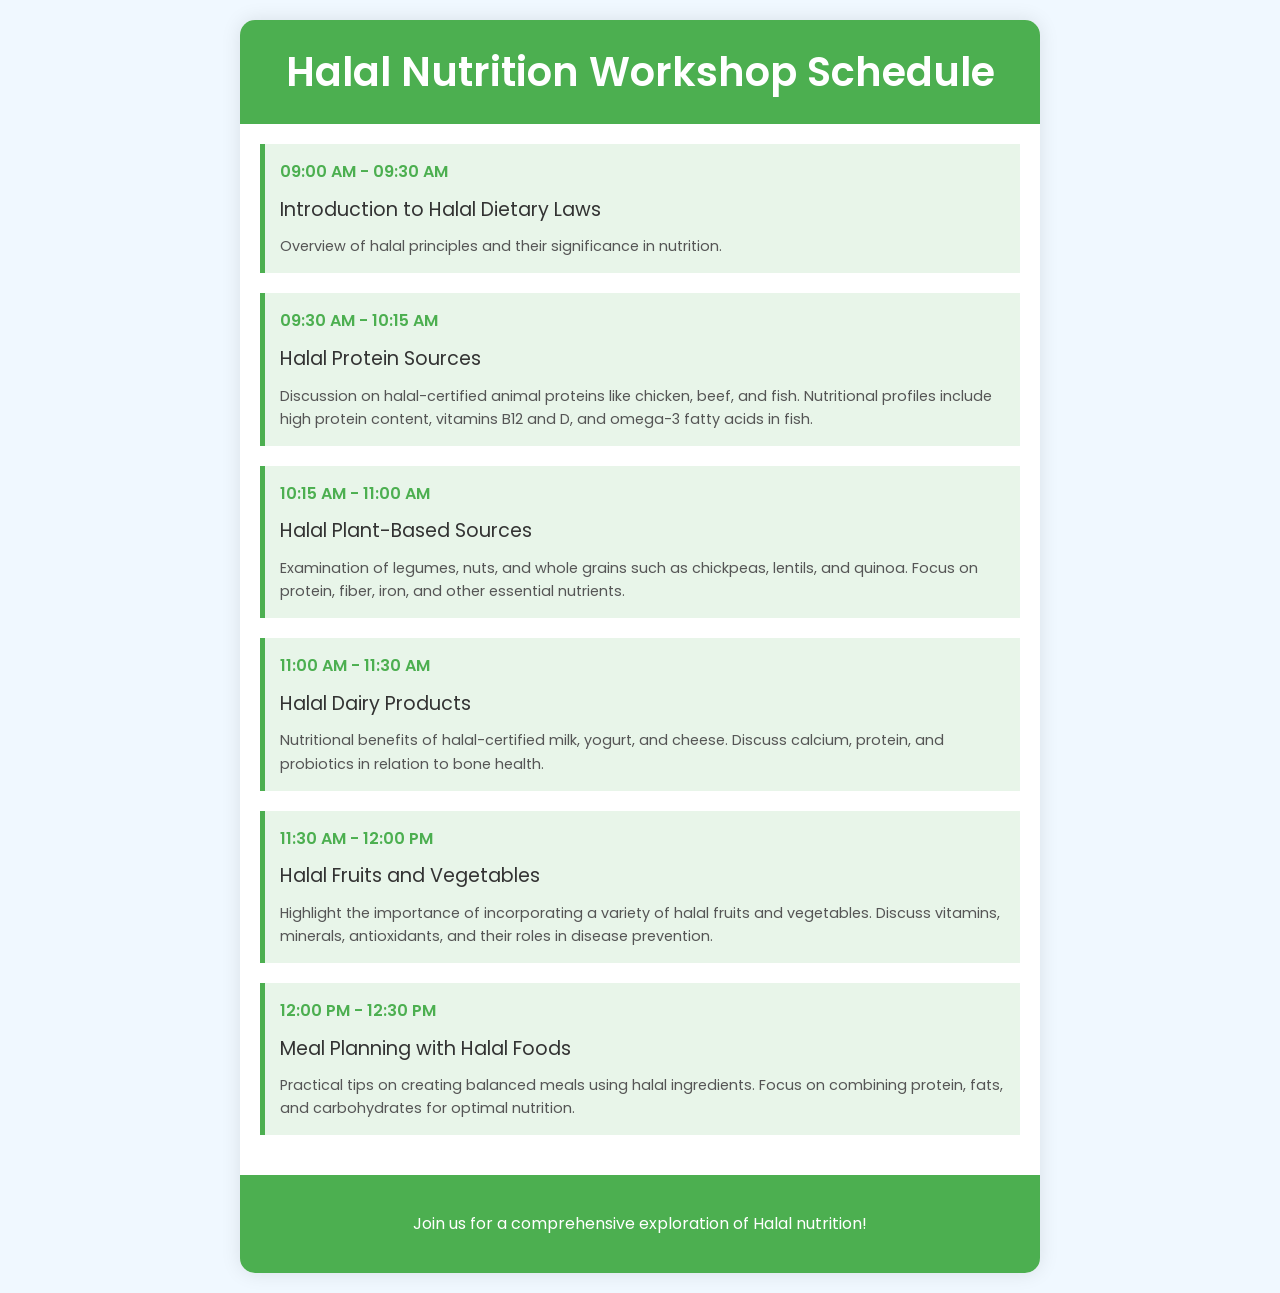what is the first session about? The first session title is "Introduction to Halal Dietary Laws," and it covers an overview of halal principles and their significance in nutrition.
Answer: Introduction to Halal Dietary Laws what time does the Halal Protein Sources session start? The session on Halal Protein Sources starts at 09:30 AM according to the schedule.
Answer: 09:30 AM which nutrients are highlighted in Halal Plant-Based Sources? The Halal Plant-Based Sources session discusses protein, fiber, iron, and other essential nutrients from legumes, nuts, and whole grains.
Answer: protein, fiber, iron how long is the Halal Dairy Products session? The Halal Dairy Products session is scheduled for 30 minutes, from 11:00 AM to 11:30 AM.
Answer: 30 minutes what is the focus of the Meal Planning with Halal Foods session? The session focuses on practical tips for creating balanced meals using halal ingredients, particularly on combining protein, fats, and carbohydrates.
Answer: balanced meals how many sessions are there in total? The schedule lists a total of six sessions focused on various aspects of halal nutrition.
Answer: six sessions what is the main purpose of the workshop? The main purpose of the workshop is to explore Halal nutrition comprehensively, as indicated in the footer.
Answer: comprehensive exploration of Halal nutrition which session covers the benefits of fruits and vegetables? The session titled "Halal Fruits and Vegetables" covers the importance and benefits of incorporating a variety of halal fruits and vegetables.
Answer: Halal Fruits and Vegetables 